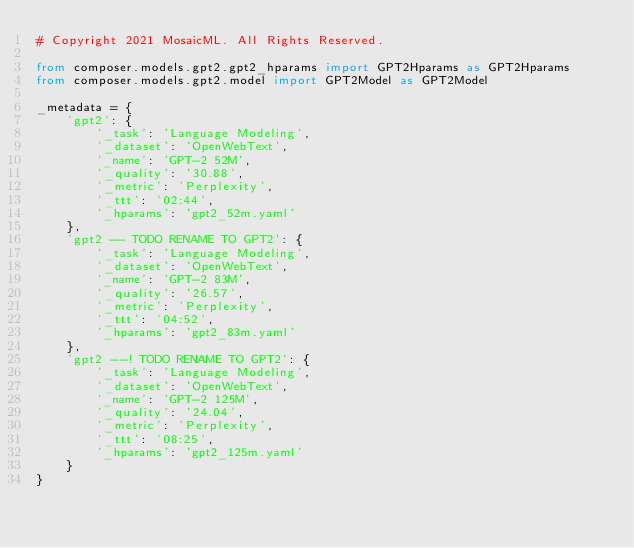Convert code to text. <code><loc_0><loc_0><loc_500><loc_500><_Python_># Copyright 2021 MosaicML. All Rights Reserved.

from composer.models.gpt2.gpt2_hparams import GPT2Hparams as GPT2Hparams
from composer.models.gpt2.model import GPT2Model as GPT2Model

_metadata = {
    'gpt2': {
        '_task': 'Language Modeling',
        '_dataset': 'OpenWebText',
        '_name': 'GPT-2 52M',
        '_quality': '30.88',
        '_metric': 'Perplexity',
        '_ttt': '02:44',
        '_hparams': 'gpt2_52m.yaml'
    },
    'gpt2 -- TODO RENAME TO GPT2': {
        '_task': 'Language Modeling',
        '_dataset': 'OpenWebText',
        '_name': 'GPT-2 83M',
        '_quality': '26.57',
        '_metric': 'Perplexity',
        '_ttt': '04:52',
        '_hparams': 'gpt2_83m.yaml'
    },
    'gpt2 --! TODO RENAME TO GPT2': {
        '_task': 'Language Modeling',
        '_dataset': 'OpenWebText',
        '_name': 'GPT-2 125M',
        '_quality': '24.04',
        '_metric': 'Perplexity',
        '_ttt': '08:25',
        '_hparams': 'gpt2_125m.yaml'
    }
}</code> 